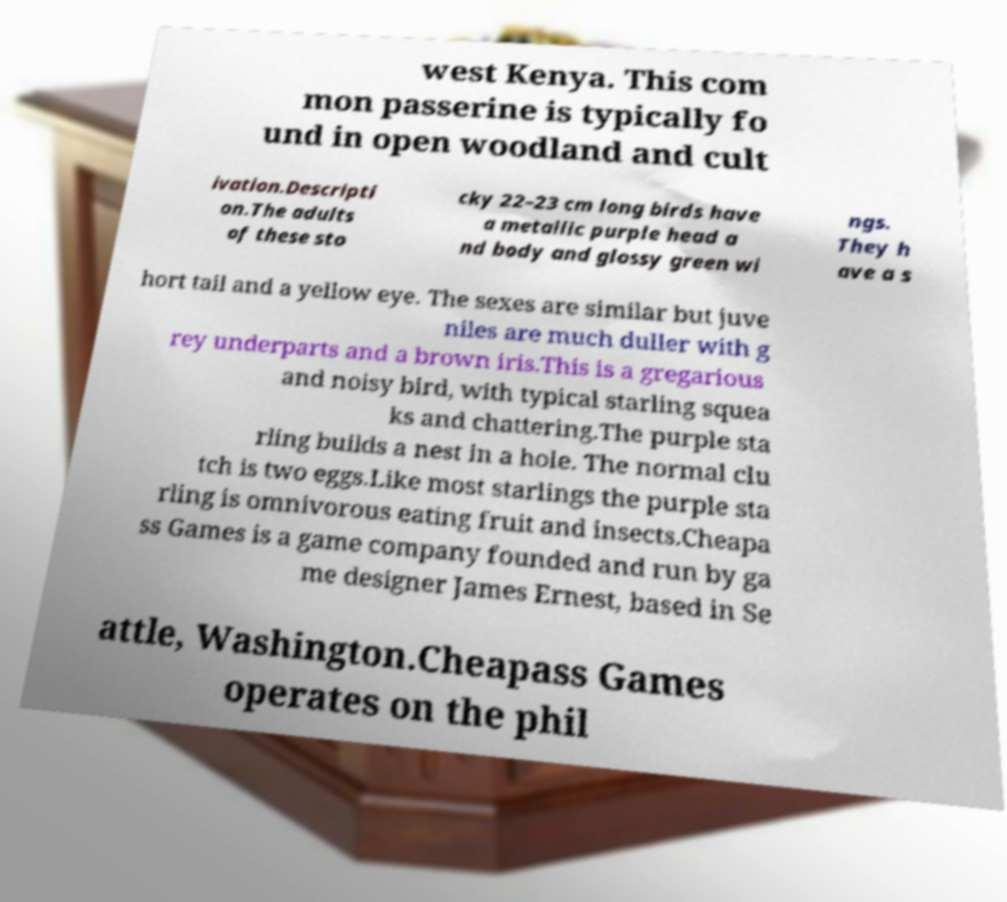Please identify and transcribe the text found in this image. west Kenya. This com mon passerine is typically fo und in open woodland and cult ivation.Descripti on.The adults of these sto cky 22–23 cm long birds have a metallic purple head a nd body and glossy green wi ngs. They h ave a s hort tail and a yellow eye. The sexes are similar but juve niles are much duller with g rey underparts and a brown iris.This is a gregarious and noisy bird, with typical starling squea ks and chattering.The purple sta rling builds a nest in a hole. The normal clu tch is two eggs.Like most starlings the purple sta rling is omnivorous eating fruit and insects.Cheapa ss Games is a game company founded and run by ga me designer James Ernest, based in Se attle, Washington.Cheapass Games operates on the phil 